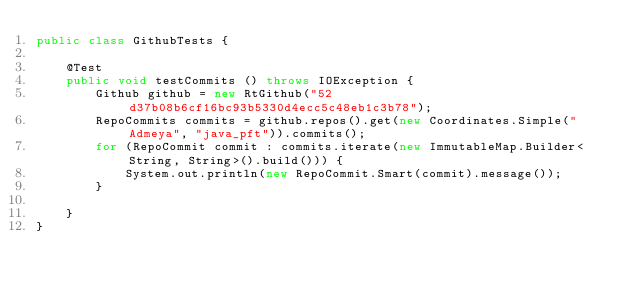Convert code to text. <code><loc_0><loc_0><loc_500><loc_500><_Java_>public class GithubTests {

    @Test
    public void testCommits () throws IOException {
        Github github = new RtGithub("52d37b08b6cf16bc93b5330d4ecc5c48eb1c3b78");
        RepoCommits commits = github.repos().get(new Coordinates.Simple("Admeya", "java_pft")).commits();
        for (RepoCommit commit : commits.iterate(new ImmutableMap.Builder<String, String>().build())) {
            System.out.println(new RepoCommit.Smart(commit).message());
        }

    }
}
</code> 